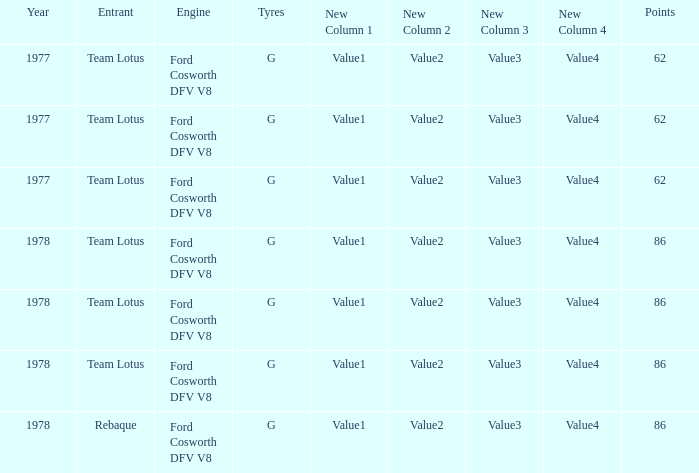What is the Motor that has a Focuses bigger than 62, and a Participant of rebaque? Ford Cosworth DFV V8. 